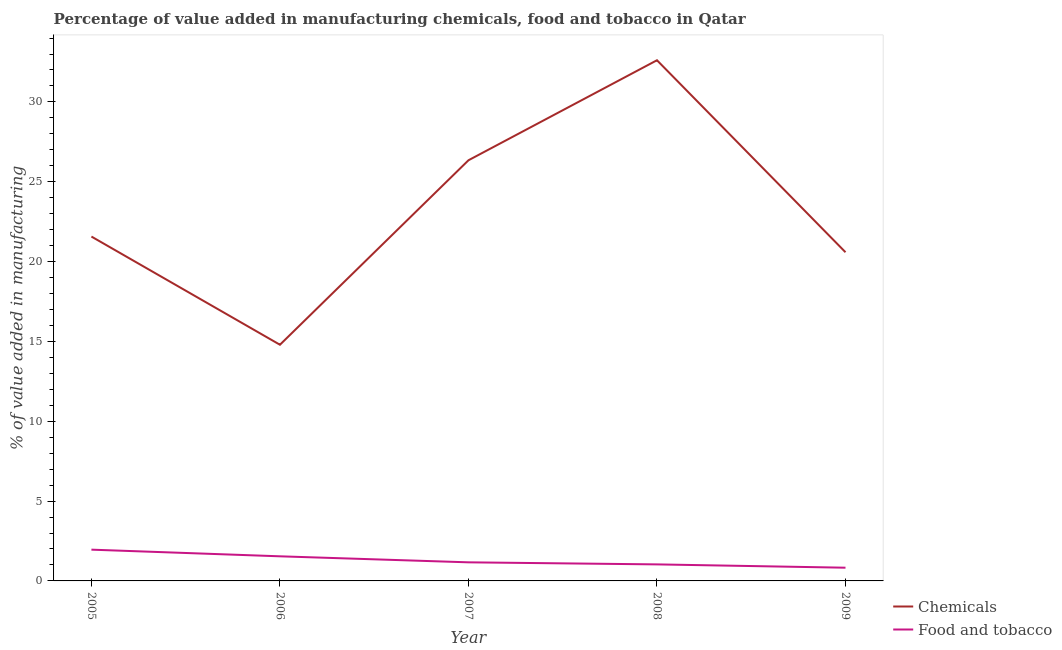How many different coloured lines are there?
Keep it short and to the point. 2. Is the number of lines equal to the number of legend labels?
Keep it short and to the point. Yes. What is the value added by manufacturing food and tobacco in 2009?
Offer a very short reply. 0.83. Across all years, what is the maximum value added by manufacturing food and tobacco?
Your response must be concise. 1.96. Across all years, what is the minimum value added by manufacturing food and tobacco?
Give a very brief answer. 0.83. In which year was the value added by manufacturing food and tobacco maximum?
Your answer should be compact. 2005. In which year was the value added by  manufacturing chemicals minimum?
Offer a terse response. 2006. What is the total value added by  manufacturing chemicals in the graph?
Provide a succinct answer. 115.9. What is the difference between the value added by manufacturing food and tobacco in 2005 and that in 2009?
Ensure brevity in your answer.  1.13. What is the difference between the value added by  manufacturing chemicals in 2009 and the value added by manufacturing food and tobacco in 2005?
Ensure brevity in your answer.  18.63. What is the average value added by manufacturing food and tobacco per year?
Offer a terse response. 1.31. In the year 2008, what is the difference between the value added by manufacturing food and tobacco and value added by  manufacturing chemicals?
Provide a succinct answer. -31.58. What is the ratio of the value added by  manufacturing chemicals in 2007 to that in 2009?
Offer a terse response. 1.28. Is the value added by manufacturing food and tobacco in 2005 less than that in 2007?
Your answer should be very brief. No. What is the difference between the highest and the second highest value added by manufacturing food and tobacco?
Your answer should be very brief. 0.42. What is the difference between the highest and the lowest value added by  manufacturing chemicals?
Provide a short and direct response. 17.82. In how many years, is the value added by manufacturing food and tobacco greater than the average value added by manufacturing food and tobacco taken over all years?
Provide a succinct answer. 2. Is the sum of the value added by manufacturing food and tobacco in 2006 and 2008 greater than the maximum value added by  manufacturing chemicals across all years?
Provide a short and direct response. No. Does the value added by manufacturing food and tobacco monotonically increase over the years?
Your response must be concise. No. Is the value added by manufacturing food and tobacco strictly greater than the value added by  manufacturing chemicals over the years?
Your response must be concise. No. How many lines are there?
Keep it short and to the point. 2. Does the graph contain any zero values?
Give a very brief answer. No. Where does the legend appear in the graph?
Your answer should be compact. Bottom right. What is the title of the graph?
Your answer should be very brief. Percentage of value added in manufacturing chemicals, food and tobacco in Qatar. Does "Transport services" appear as one of the legend labels in the graph?
Your answer should be compact. No. What is the label or title of the X-axis?
Offer a very short reply. Year. What is the label or title of the Y-axis?
Give a very brief answer. % of value added in manufacturing. What is the % of value added in manufacturing in Chemicals in 2005?
Provide a short and direct response. 21.57. What is the % of value added in manufacturing of Food and tobacco in 2005?
Make the answer very short. 1.96. What is the % of value added in manufacturing of Chemicals in 2006?
Make the answer very short. 14.79. What is the % of value added in manufacturing in Food and tobacco in 2006?
Offer a very short reply. 1.54. What is the % of value added in manufacturing in Chemicals in 2007?
Offer a very short reply. 26.35. What is the % of value added in manufacturing of Food and tobacco in 2007?
Ensure brevity in your answer.  1.16. What is the % of value added in manufacturing in Chemicals in 2008?
Your response must be concise. 32.61. What is the % of value added in manufacturing of Food and tobacco in 2008?
Your answer should be compact. 1.04. What is the % of value added in manufacturing in Chemicals in 2009?
Keep it short and to the point. 20.59. What is the % of value added in manufacturing in Food and tobacco in 2009?
Make the answer very short. 0.83. Across all years, what is the maximum % of value added in manufacturing of Chemicals?
Your answer should be very brief. 32.61. Across all years, what is the maximum % of value added in manufacturing in Food and tobacco?
Give a very brief answer. 1.96. Across all years, what is the minimum % of value added in manufacturing of Chemicals?
Keep it short and to the point. 14.79. Across all years, what is the minimum % of value added in manufacturing in Food and tobacco?
Give a very brief answer. 0.83. What is the total % of value added in manufacturing of Chemicals in the graph?
Offer a very short reply. 115.9. What is the total % of value added in manufacturing in Food and tobacco in the graph?
Ensure brevity in your answer.  6.53. What is the difference between the % of value added in manufacturing of Chemicals in 2005 and that in 2006?
Provide a short and direct response. 6.78. What is the difference between the % of value added in manufacturing of Food and tobacco in 2005 and that in 2006?
Keep it short and to the point. 0.42. What is the difference between the % of value added in manufacturing in Chemicals in 2005 and that in 2007?
Your response must be concise. -4.78. What is the difference between the % of value added in manufacturing of Food and tobacco in 2005 and that in 2007?
Your response must be concise. 0.79. What is the difference between the % of value added in manufacturing of Chemicals in 2005 and that in 2008?
Offer a terse response. -11.04. What is the difference between the % of value added in manufacturing of Food and tobacco in 2005 and that in 2008?
Provide a succinct answer. 0.92. What is the difference between the % of value added in manufacturing in Chemicals in 2005 and that in 2009?
Make the answer very short. 0.98. What is the difference between the % of value added in manufacturing of Food and tobacco in 2005 and that in 2009?
Your response must be concise. 1.13. What is the difference between the % of value added in manufacturing in Chemicals in 2006 and that in 2007?
Your answer should be very brief. -11.55. What is the difference between the % of value added in manufacturing in Food and tobacco in 2006 and that in 2007?
Provide a succinct answer. 0.38. What is the difference between the % of value added in manufacturing in Chemicals in 2006 and that in 2008?
Offer a terse response. -17.82. What is the difference between the % of value added in manufacturing of Food and tobacco in 2006 and that in 2008?
Your answer should be compact. 0.51. What is the difference between the % of value added in manufacturing of Chemicals in 2006 and that in 2009?
Make the answer very short. -5.79. What is the difference between the % of value added in manufacturing of Food and tobacco in 2006 and that in 2009?
Provide a succinct answer. 0.71. What is the difference between the % of value added in manufacturing of Chemicals in 2007 and that in 2008?
Keep it short and to the point. -6.27. What is the difference between the % of value added in manufacturing in Food and tobacco in 2007 and that in 2008?
Keep it short and to the point. 0.13. What is the difference between the % of value added in manufacturing of Chemicals in 2007 and that in 2009?
Ensure brevity in your answer.  5.76. What is the difference between the % of value added in manufacturing of Food and tobacco in 2007 and that in 2009?
Ensure brevity in your answer.  0.34. What is the difference between the % of value added in manufacturing of Chemicals in 2008 and that in 2009?
Offer a very short reply. 12.03. What is the difference between the % of value added in manufacturing in Food and tobacco in 2008 and that in 2009?
Offer a terse response. 0.21. What is the difference between the % of value added in manufacturing in Chemicals in 2005 and the % of value added in manufacturing in Food and tobacco in 2006?
Provide a short and direct response. 20.03. What is the difference between the % of value added in manufacturing of Chemicals in 2005 and the % of value added in manufacturing of Food and tobacco in 2007?
Your answer should be compact. 20.4. What is the difference between the % of value added in manufacturing in Chemicals in 2005 and the % of value added in manufacturing in Food and tobacco in 2008?
Provide a succinct answer. 20.53. What is the difference between the % of value added in manufacturing in Chemicals in 2005 and the % of value added in manufacturing in Food and tobacco in 2009?
Offer a terse response. 20.74. What is the difference between the % of value added in manufacturing in Chemicals in 2006 and the % of value added in manufacturing in Food and tobacco in 2007?
Your answer should be compact. 13.63. What is the difference between the % of value added in manufacturing of Chemicals in 2006 and the % of value added in manufacturing of Food and tobacco in 2008?
Provide a succinct answer. 13.76. What is the difference between the % of value added in manufacturing in Chemicals in 2006 and the % of value added in manufacturing in Food and tobacco in 2009?
Your answer should be very brief. 13.96. What is the difference between the % of value added in manufacturing in Chemicals in 2007 and the % of value added in manufacturing in Food and tobacco in 2008?
Provide a short and direct response. 25.31. What is the difference between the % of value added in manufacturing in Chemicals in 2007 and the % of value added in manufacturing in Food and tobacco in 2009?
Provide a succinct answer. 25.52. What is the difference between the % of value added in manufacturing in Chemicals in 2008 and the % of value added in manufacturing in Food and tobacco in 2009?
Keep it short and to the point. 31.78. What is the average % of value added in manufacturing of Chemicals per year?
Provide a succinct answer. 23.18. What is the average % of value added in manufacturing of Food and tobacco per year?
Provide a succinct answer. 1.31. In the year 2005, what is the difference between the % of value added in manufacturing of Chemicals and % of value added in manufacturing of Food and tobacco?
Your response must be concise. 19.61. In the year 2006, what is the difference between the % of value added in manufacturing in Chemicals and % of value added in manufacturing in Food and tobacco?
Give a very brief answer. 13.25. In the year 2007, what is the difference between the % of value added in manufacturing of Chemicals and % of value added in manufacturing of Food and tobacco?
Your answer should be compact. 25.18. In the year 2008, what is the difference between the % of value added in manufacturing of Chemicals and % of value added in manufacturing of Food and tobacco?
Offer a terse response. 31.58. In the year 2009, what is the difference between the % of value added in manufacturing in Chemicals and % of value added in manufacturing in Food and tobacco?
Ensure brevity in your answer.  19.76. What is the ratio of the % of value added in manufacturing of Chemicals in 2005 to that in 2006?
Your answer should be compact. 1.46. What is the ratio of the % of value added in manufacturing in Food and tobacco in 2005 to that in 2006?
Keep it short and to the point. 1.27. What is the ratio of the % of value added in manufacturing of Chemicals in 2005 to that in 2007?
Keep it short and to the point. 0.82. What is the ratio of the % of value added in manufacturing of Food and tobacco in 2005 to that in 2007?
Provide a short and direct response. 1.68. What is the ratio of the % of value added in manufacturing of Chemicals in 2005 to that in 2008?
Make the answer very short. 0.66. What is the ratio of the % of value added in manufacturing in Food and tobacco in 2005 to that in 2008?
Your response must be concise. 1.89. What is the ratio of the % of value added in manufacturing in Chemicals in 2005 to that in 2009?
Give a very brief answer. 1.05. What is the ratio of the % of value added in manufacturing of Food and tobacco in 2005 to that in 2009?
Make the answer very short. 2.37. What is the ratio of the % of value added in manufacturing of Chemicals in 2006 to that in 2007?
Keep it short and to the point. 0.56. What is the ratio of the % of value added in manufacturing of Food and tobacco in 2006 to that in 2007?
Keep it short and to the point. 1.32. What is the ratio of the % of value added in manufacturing of Chemicals in 2006 to that in 2008?
Your response must be concise. 0.45. What is the ratio of the % of value added in manufacturing in Food and tobacco in 2006 to that in 2008?
Provide a short and direct response. 1.49. What is the ratio of the % of value added in manufacturing in Chemicals in 2006 to that in 2009?
Provide a short and direct response. 0.72. What is the ratio of the % of value added in manufacturing of Food and tobacco in 2006 to that in 2009?
Offer a terse response. 1.86. What is the ratio of the % of value added in manufacturing in Chemicals in 2007 to that in 2008?
Keep it short and to the point. 0.81. What is the ratio of the % of value added in manufacturing of Food and tobacco in 2007 to that in 2008?
Give a very brief answer. 1.12. What is the ratio of the % of value added in manufacturing in Chemicals in 2007 to that in 2009?
Make the answer very short. 1.28. What is the ratio of the % of value added in manufacturing in Food and tobacco in 2007 to that in 2009?
Your response must be concise. 1.41. What is the ratio of the % of value added in manufacturing in Chemicals in 2008 to that in 2009?
Provide a succinct answer. 1.58. What is the ratio of the % of value added in manufacturing in Food and tobacco in 2008 to that in 2009?
Your answer should be very brief. 1.25. What is the difference between the highest and the second highest % of value added in manufacturing in Chemicals?
Offer a very short reply. 6.27. What is the difference between the highest and the second highest % of value added in manufacturing in Food and tobacco?
Offer a terse response. 0.42. What is the difference between the highest and the lowest % of value added in manufacturing of Chemicals?
Your answer should be compact. 17.82. What is the difference between the highest and the lowest % of value added in manufacturing of Food and tobacco?
Offer a terse response. 1.13. 